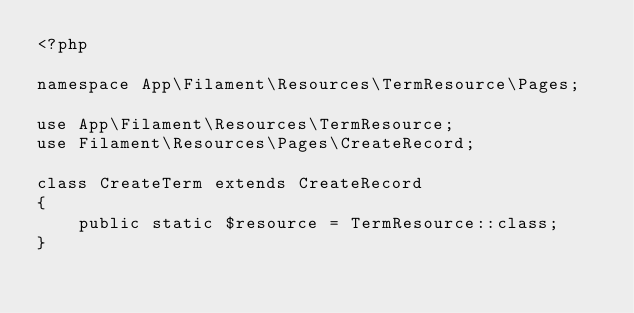<code> <loc_0><loc_0><loc_500><loc_500><_PHP_><?php

namespace App\Filament\Resources\TermResource\Pages;

use App\Filament\Resources\TermResource;
use Filament\Resources\Pages\CreateRecord;

class CreateTerm extends CreateRecord
{
    public static $resource = TermResource::class;
}
</code> 